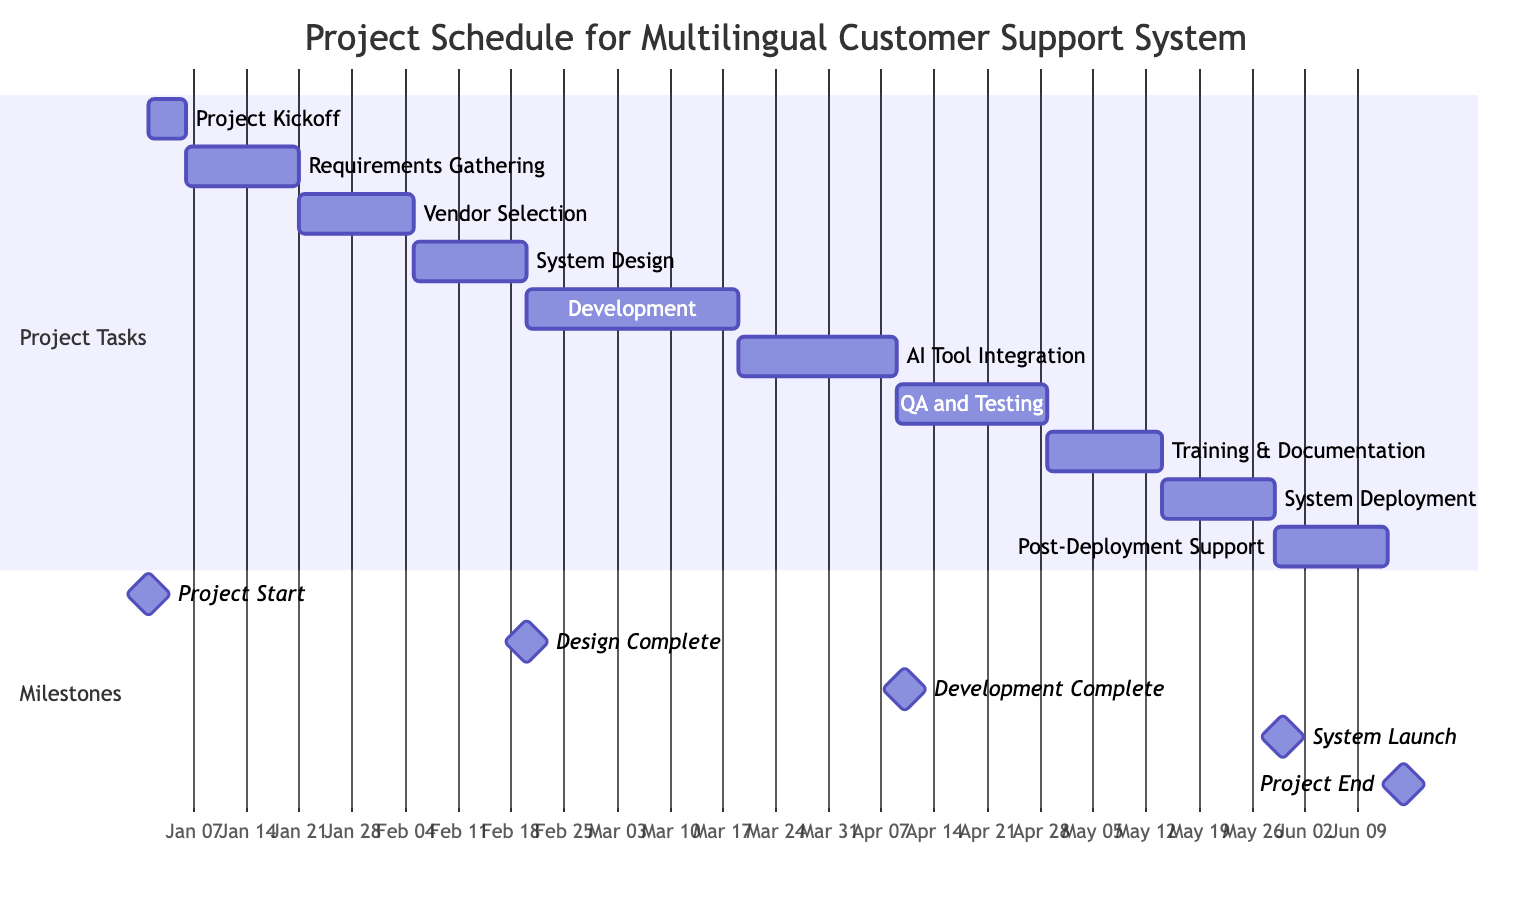What is the duration of the "Requirements Gathering" task? The "Requirements Gathering" task begins on January 6 and ends on January 20, making its duration 15 days.
Answer: 15 days What task follows "System Design and Architecture"? Looking at the sequence of tasks, "Development of Multilingual Support Features" directly follows "System Design and Architecture".
Answer: Development of Multilingual Support Features How many total tasks are listed in the project schedule? By counting all the tasks in the project schedule section, there are 10 tasks listed in total.
Answer: 10 What is the end date of the "Quality Assurance and Testing" task? The "Quality Assurance and Testing" task ends on April 30, as per the provided schedule.
Answer: April 30 What milestone indicates the completion of the system design phase? The milestone "Design Complete" corresponds with the end date of the "System Design and Architecture" task, indicating the completion of the design phase.
Answer: Design Complete When does the "Deployment of Multilingual System" start? According to the timeline, the "Deployment of Multilingual System" starts on May 16.
Answer: May 16 What is the duration of the "Integration of AI Translation Tools"? The task "Integration of AI Translation Tools" has a duration of 21 days, as calculated from March 21 to April 10.
Answer: 21 days Which task occurs immediately after the "AI Tool Integration"? Directly after "AI Tool Integration", the next task is "Quality Assurance and Testing".
Answer: Quality Assurance and Testing What is the milestone date for the project end? The project end is marked by the milestone "Project End" which occurs on June 15.
Answer: June 15 